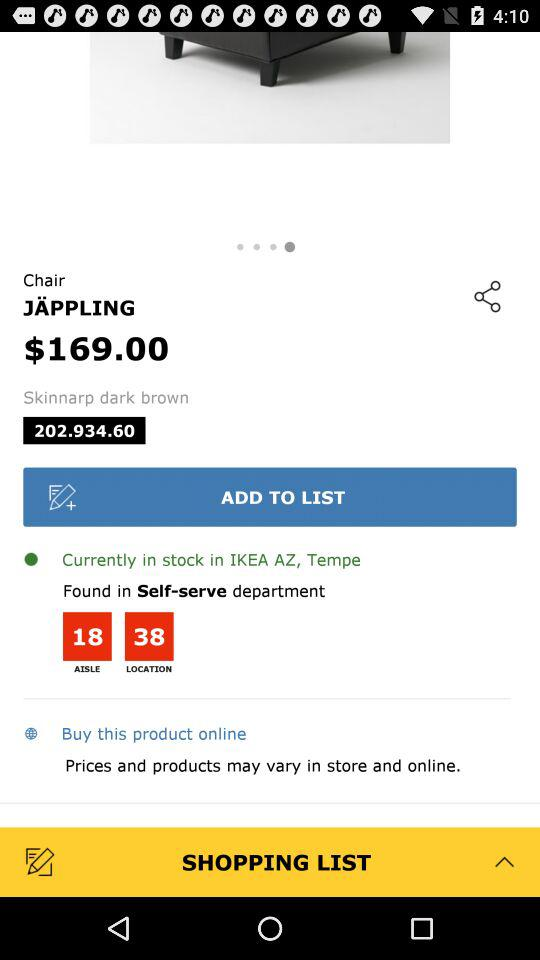What is the price of the chair?
Answer the question using a single word or phrase. $169.00 